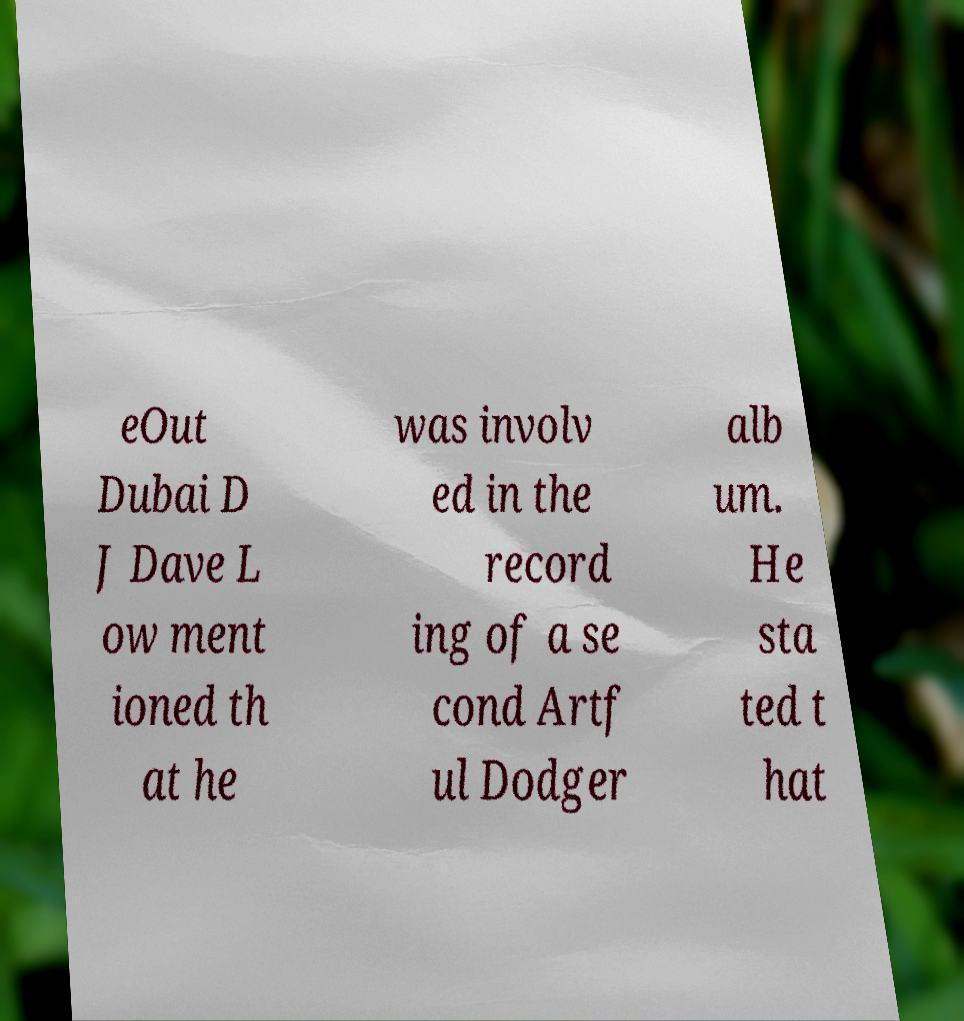Can you accurately transcribe the text from the provided image for me? eOut Dubai D J Dave L ow ment ioned th at he was involv ed in the record ing of a se cond Artf ul Dodger alb um. He sta ted t hat 